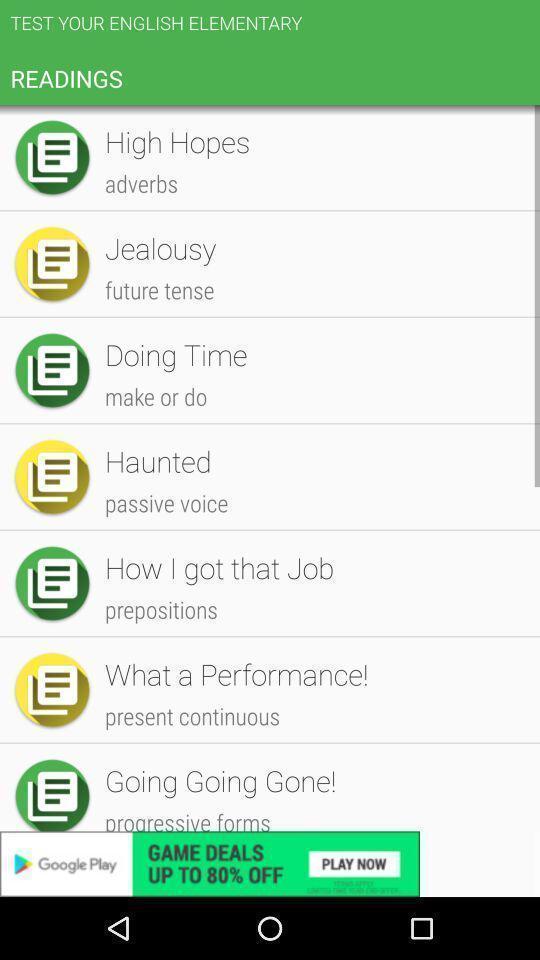Describe the content in this image. Screen shows list of readings in a learning app. 